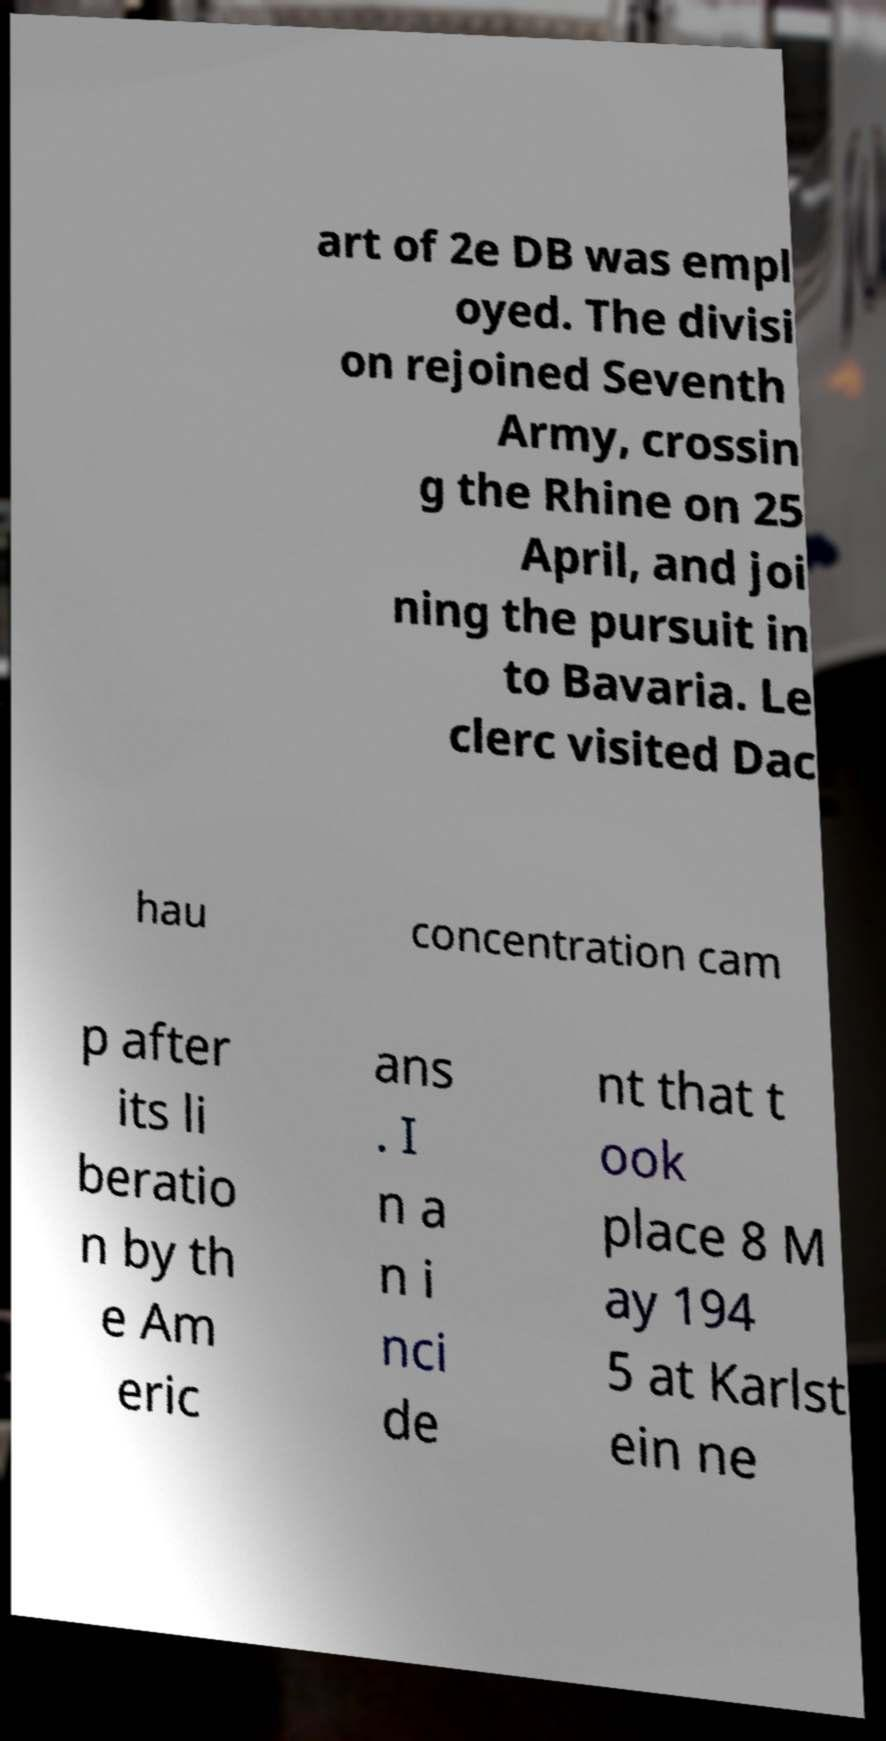Please read and relay the text visible in this image. What does it say? art of 2e DB was empl oyed. The divisi on rejoined Seventh Army, crossin g the Rhine on 25 April, and joi ning the pursuit in to Bavaria. Le clerc visited Dac hau concentration cam p after its li beratio n by th e Am eric ans . I n a n i nci de nt that t ook place 8 M ay 194 5 at Karlst ein ne 